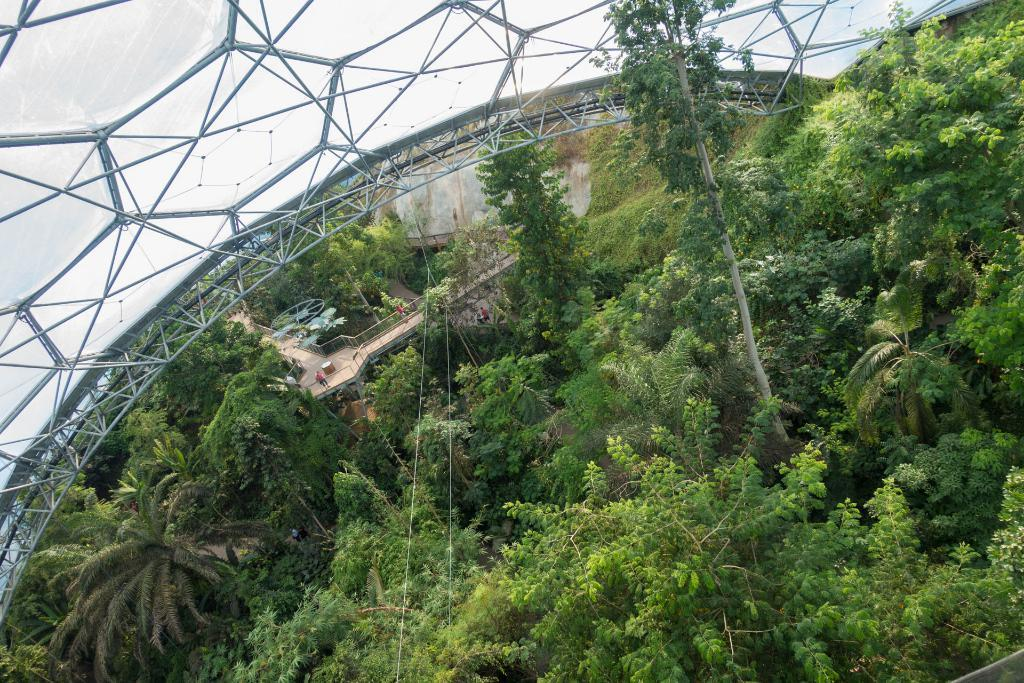What type of natural elements can be seen in the image? There are trees in the image. What man-made structure is present in the image? There is a bridge in the image. Where is the bridge located in relation to the image? The bridge is located at the bottom of the image. What type of architectural feature is present in the image? There is a glass roof in the image. Where is the glass roof located in the image? The glass roof is located at the top of the image. Can you tell me how many teeth the bridge has in the image? There are no teeth present in the image; it features a bridge over a body of water. What type of military vehicle can be seen driving through the trees in the image? There is no military vehicle or any vehicle present in the image; it only features trees, a bridge, and a glass roof. 